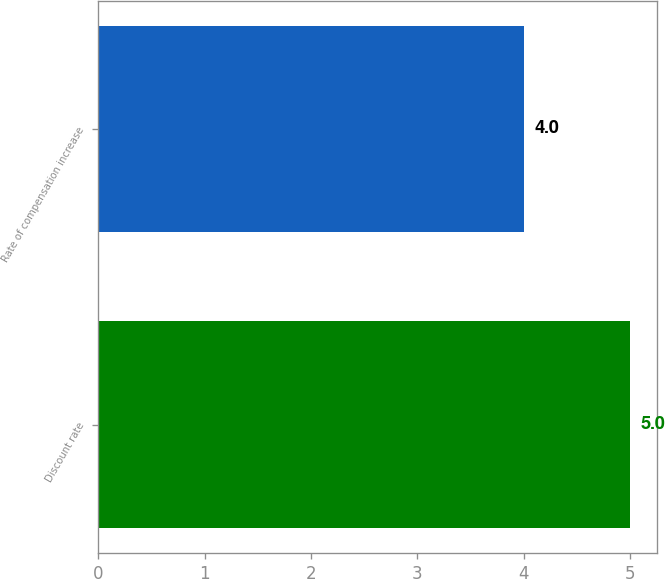Convert chart to OTSL. <chart><loc_0><loc_0><loc_500><loc_500><bar_chart><fcel>Discount rate<fcel>Rate of compensation increase<nl><fcel>5<fcel>4<nl></chart> 